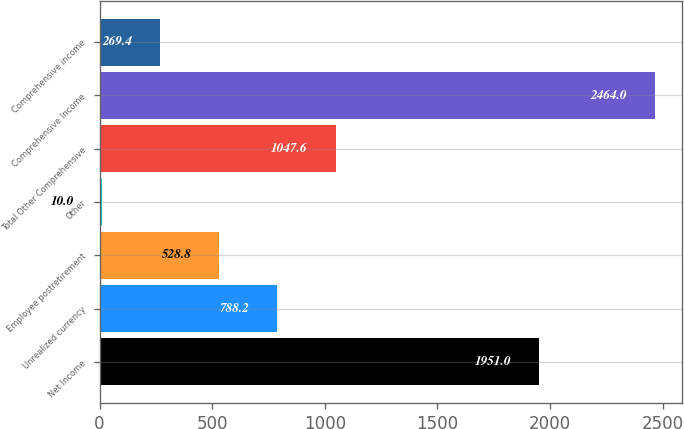Convert chart. <chart><loc_0><loc_0><loc_500><loc_500><bar_chart><fcel>Net Income<fcel>Unrealized currency<fcel>Employee postretirement<fcel>Other<fcel>Total Other Comprehensive<fcel>Comprehensive Income<fcel>Comprehensive income<nl><fcel>1951<fcel>788.2<fcel>528.8<fcel>10<fcel>1047.6<fcel>2464<fcel>269.4<nl></chart> 